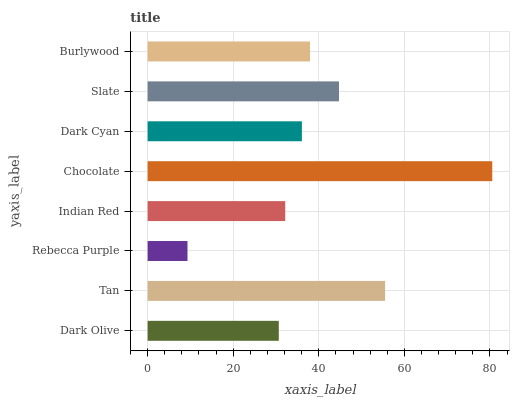Is Rebecca Purple the minimum?
Answer yes or no. Yes. Is Chocolate the maximum?
Answer yes or no. Yes. Is Tan the minimum?
Answer yes or no. No. Is Tan the maximum?
Answer yes or no. No. Is Tan greater than Dark Olive?
Answer yes or no. Yes. Is Dark Olive less than Tan?
Answer yes or no. Yes. Is Dark Olive greater than Tan?
Answer yes or no. No. Is Tan less than Dark Olive?
Answer yes or no. No. Is Burlywood the high median?
Answer yes or no. Yes. Is Dark Cyan the low median?
Answer yes or no. Yes. Is Slate the high median?
Answer yes or no. No. Is Dark Olive the low median?
Answer yes or no. No. 